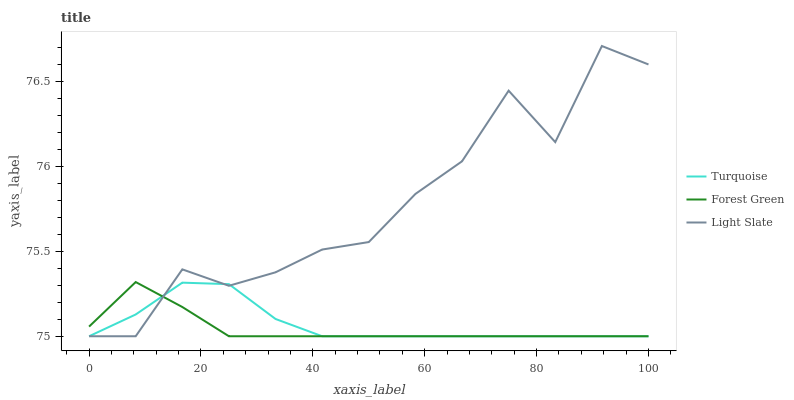Does Forest Green have the minimum area under the curve?
Answer yes or no. Yes. Does Light Slate have the maximum area under the curve?
Answer yes or no. Yes. Does Turquoise have the minimum area under the curve?
Answer yes or no. No. Does Turquoise have the maximum area under the curve?
Answer yes or no. No. Is Forest Green the smoothest?
Answer yes or no. Yes. Is Light Slate the roughest?
Answer yes or no. Yes. Is Turquoise the smoothest?
Answer yes or no. No. Is Turquoise the roughest?
Answer yes or no. No. Does Light Slate have the lowest value?
Answer yes or no. Yes. Does Light Slate have the highest value?
Answer yes or no. Yes. Does Forest Green have the highest value?
Answer yes or no. No. Does Forest Green intersect Turquoise?
Answer yes or no. Yes. Is Forest Green less than Turquoise?
Answer yes or no. No. Is Forest Green greater than Turquoise?
Answer yes or no. No. 